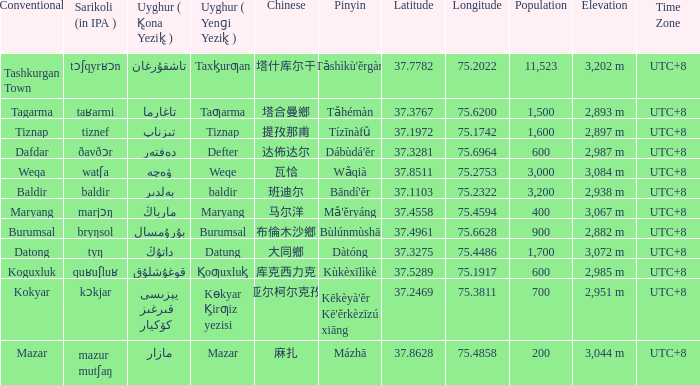Name the conventional for تاغارما Tagarma. 